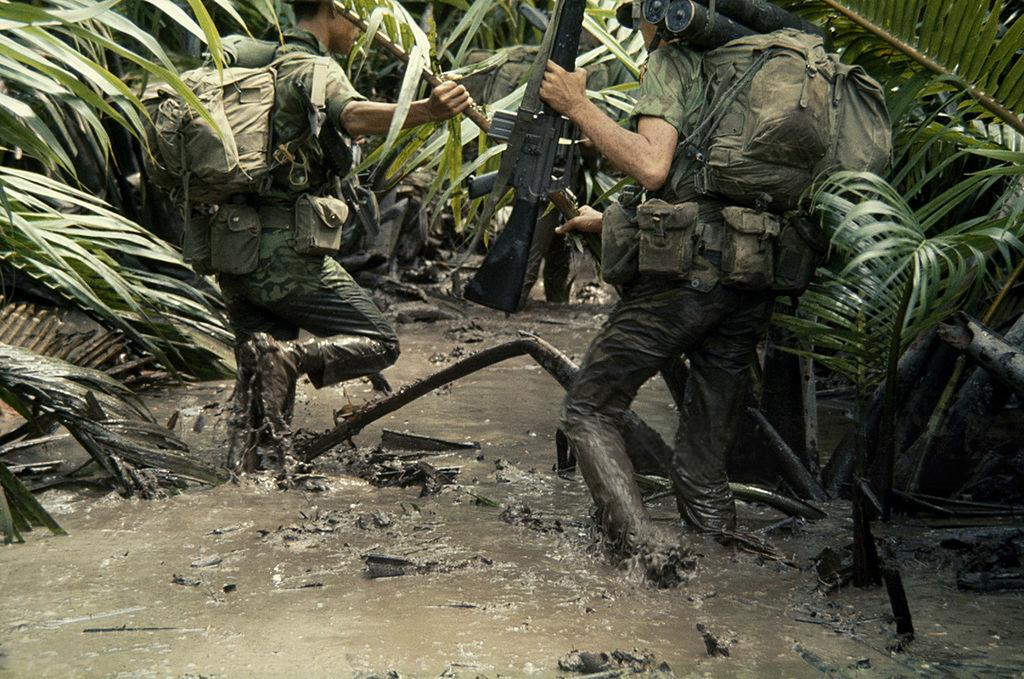How many people are in the image? There are two persons in the image. What are the persons doing in the image? The persons are standing in mud water. What can be seen in the background of the image? There are trees in the background of the image. What type of wealth can be seen in the hands of the boys in the image? There are no boys present in the image, and no wealth is visible in their hands or elsewhere. 